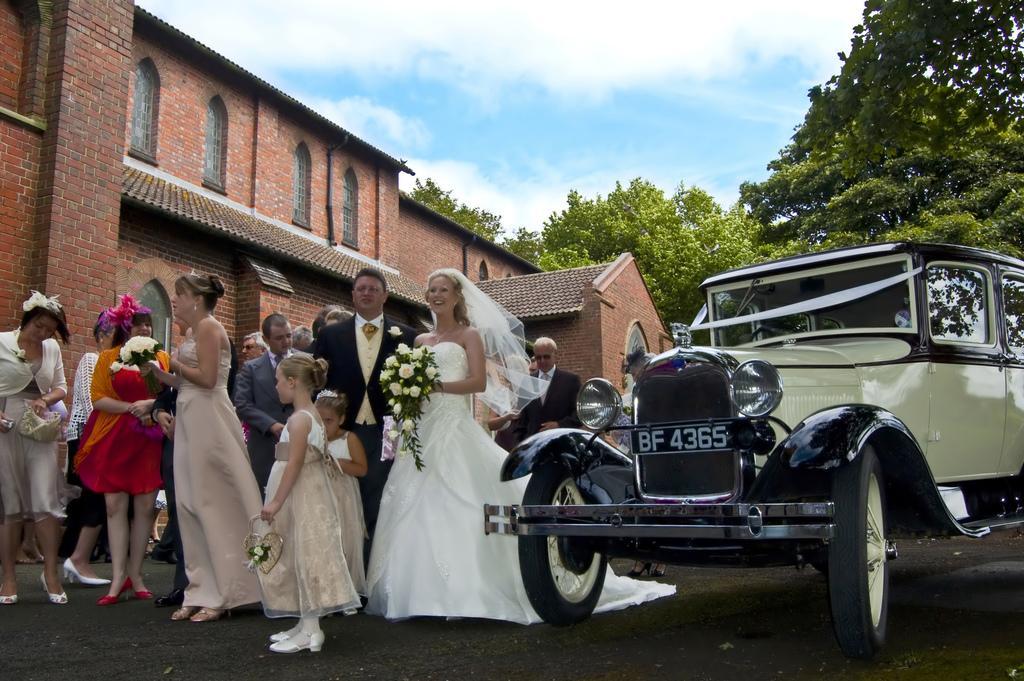Can you describe this image briefly? In this picture we can see group of people and few people holding bouquets, beside them we can see a car, in the background we can find few trees, clouds and a building. 